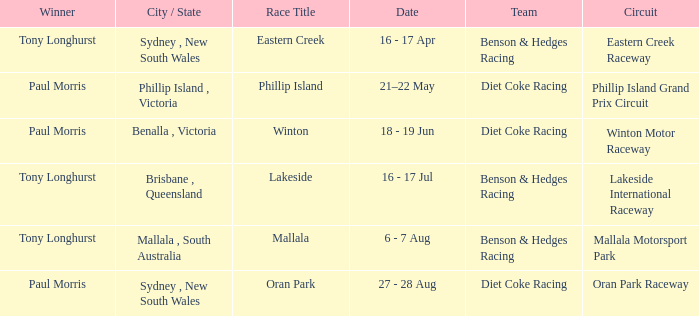What was the name of the driver that won the Lakeside race? Tony Longhurst. Help me parse the entirety of this table. {'header': ['Winner', 'City / State', 'Race Title', 'Date', 'Team', 'Circuit'], 'rows': [['Tony Longhurst', 'Sydney , New South Wales', 'Eastern Creek', '16 - 17 Apr', 'Benson & Hedges Racing', 'Eastern Creek Raceway'], ['Paul Morris', 'Phillip Island , Victoria', 'Phillip Island', '21–22 May', 'Diet Coke Racing', 'Phillip Island Grand Prix Circuit'], ['Paul Morris', 'Benalla , Victoria', 'Winton', '18 - 19 Jun', 'Diet Coke Racing', 'Winton Motor Raceway'], ['Tony Longhurst', 'Brisbane , Queensland', 'Lakeside', '16 - 17 Jul', 'Benson & Hedges Racing', 'Lakeside International Raceway'], ['Tony Longhurst', 'Mallala , South Australia', 'Mallala', '6 - 7 Aug', 'Benson & Hedges Racing', 'Mallala Motorsport Park'], ['Paul Morris', 'Sydney , New South Wales', 'Oran Park', '27 - 28 Aug', 'Diet Coke Racing', 'Oran Park Raceway']]} 